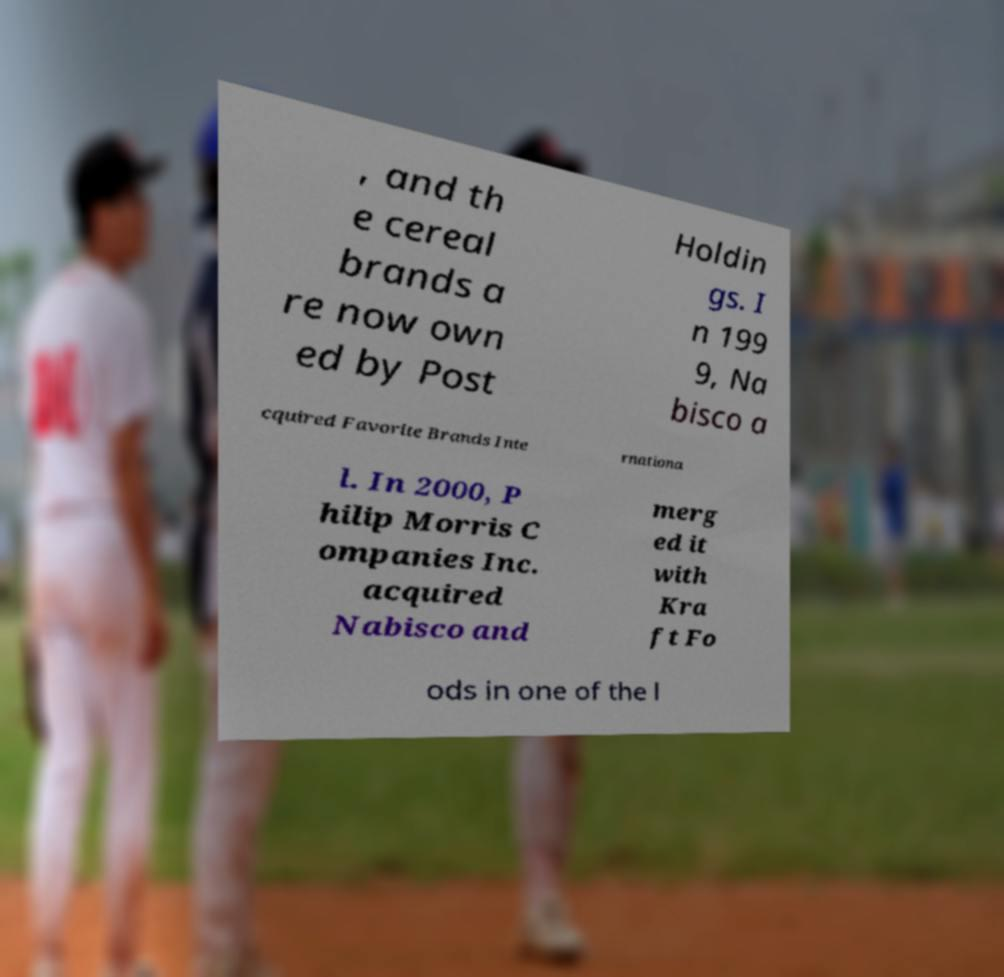Can you read and provide the text displayed in the image?This photo seems to have some interesting text. Can you extract and type it out for me? , and th e cereal brands a re now own ed by Post Holdin gs. I n 199 9, Na bisco a cquired Favorite Brands Inte rnationa l. In 2000, P hilip Morris C ompanies Inc. acquired Nabisco and merg ed it with Kra ft Fo ods in one of the l 